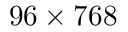Convert formula to latex. <formula><loc_0><loc_0><loc_500><loc_500>9 6 \times 7 6 8</formula> 